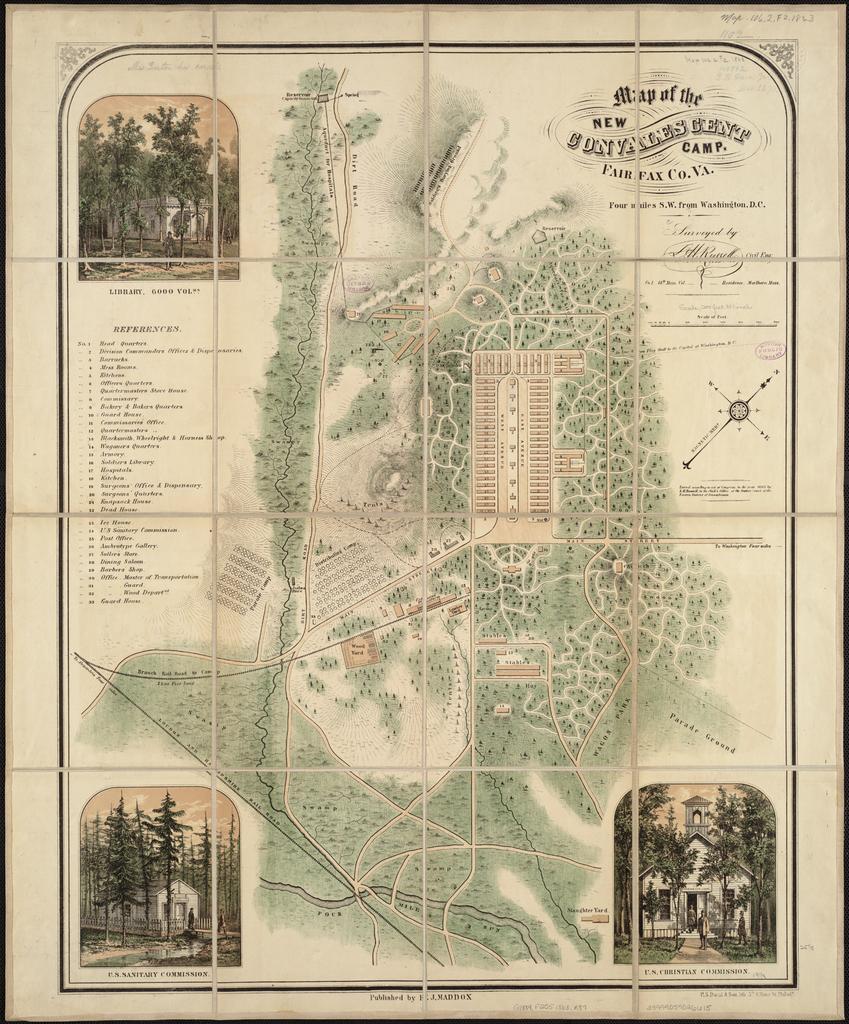Describe this image in one or two sentences. In this picture we can see a paper, there are pictures of trees, buildings and text on the paper, we can see a map in the middle. 